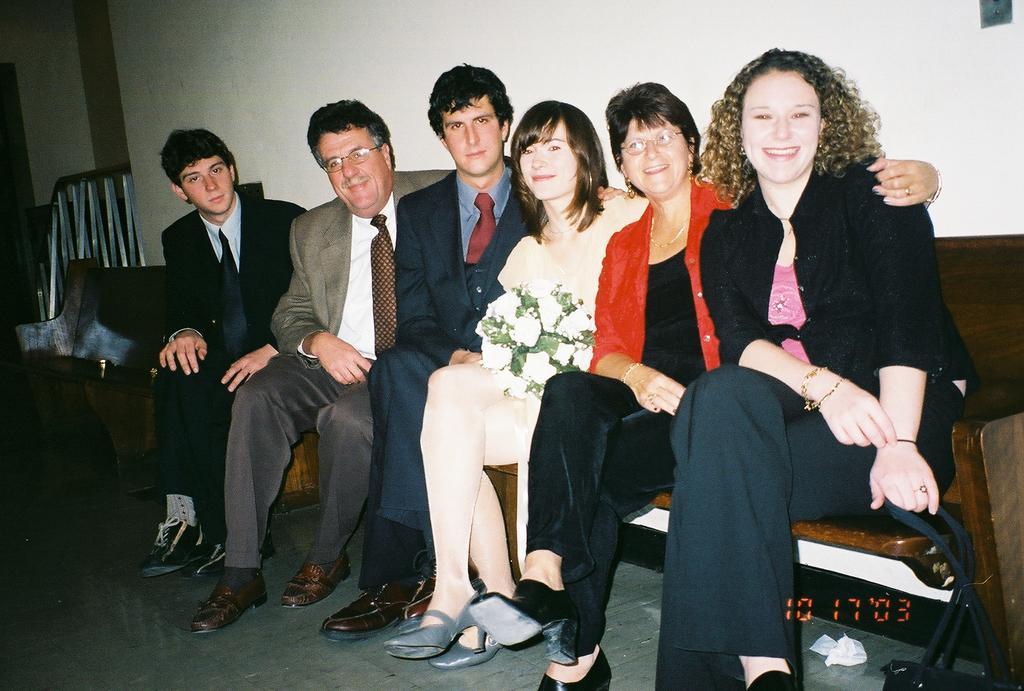In one or two sentences, can you explain what this image depicts? In this image there is a group of people sitting on a bench. At the bottom of the image there are numbers, beside them there is a metal rod fence, behind them there is a wall. 